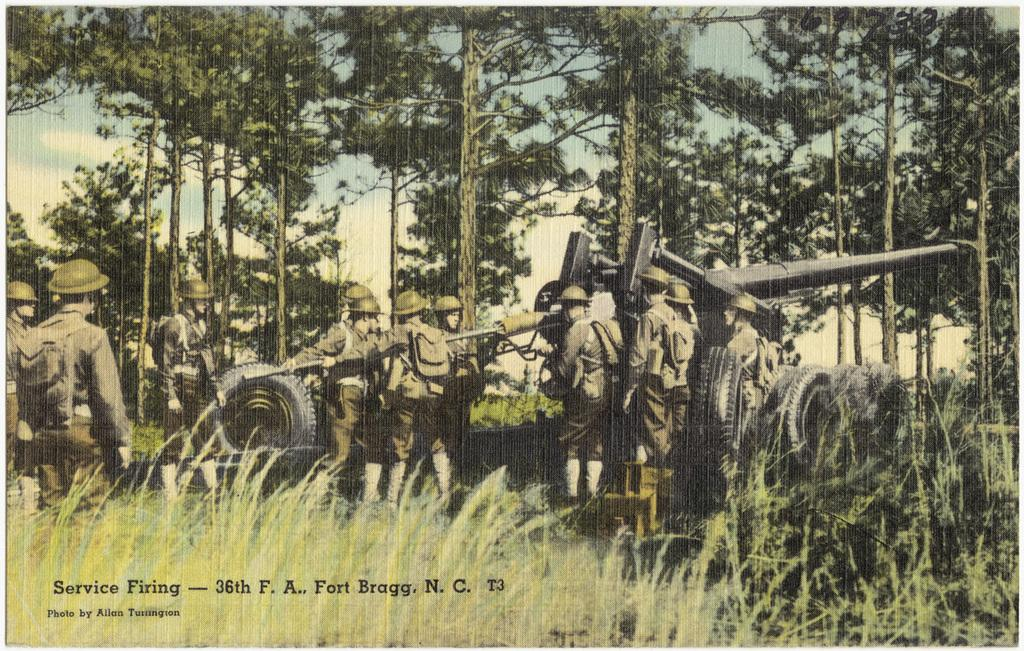What is featured on the poster in the image? The poster depicts people holding an object. What else can be seen in the image besides the poster? There are tires and grass visible in the image. What type of vegetation is in the background of the image? There are trees in the background of the image. What is visible in the sky in the image? The sky is visible in the background of the image. Can you tell me how many apples are on the poster? There is no apple present on the poster; it features people holding an object. What type of star can be seen in the image? There is no star visible in the image; it features a poster, tires, grass, trees, and the sky. 